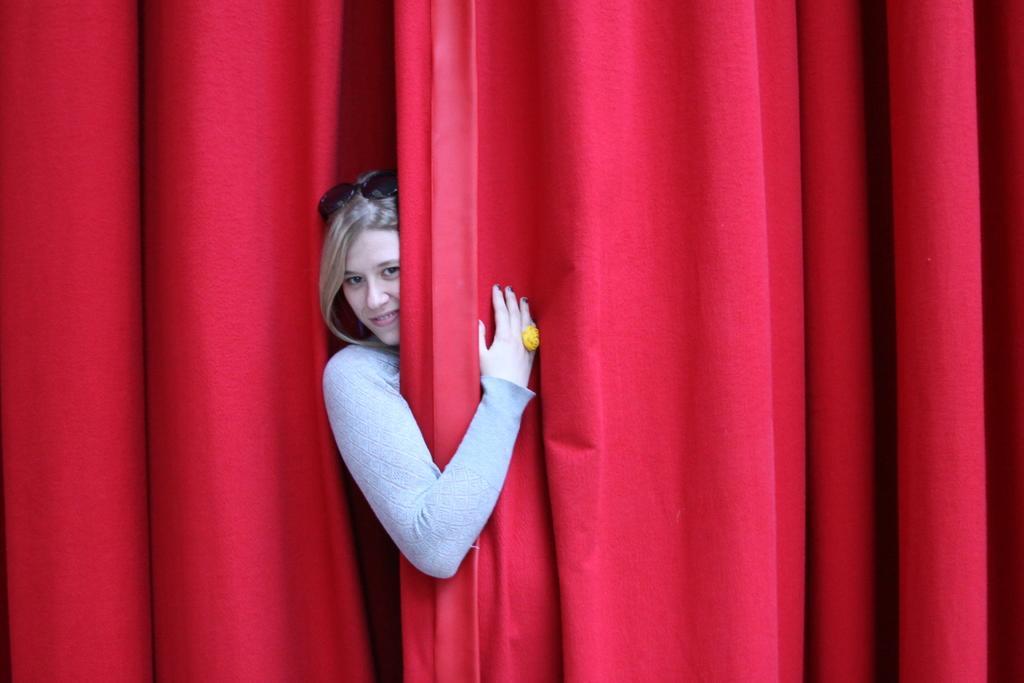Describe this image in one or two sentences. In this picture I can observe a woman wearing grey color dress. She is smiling and wearing spectacles on her head. The woman is behind the red color curtain. 